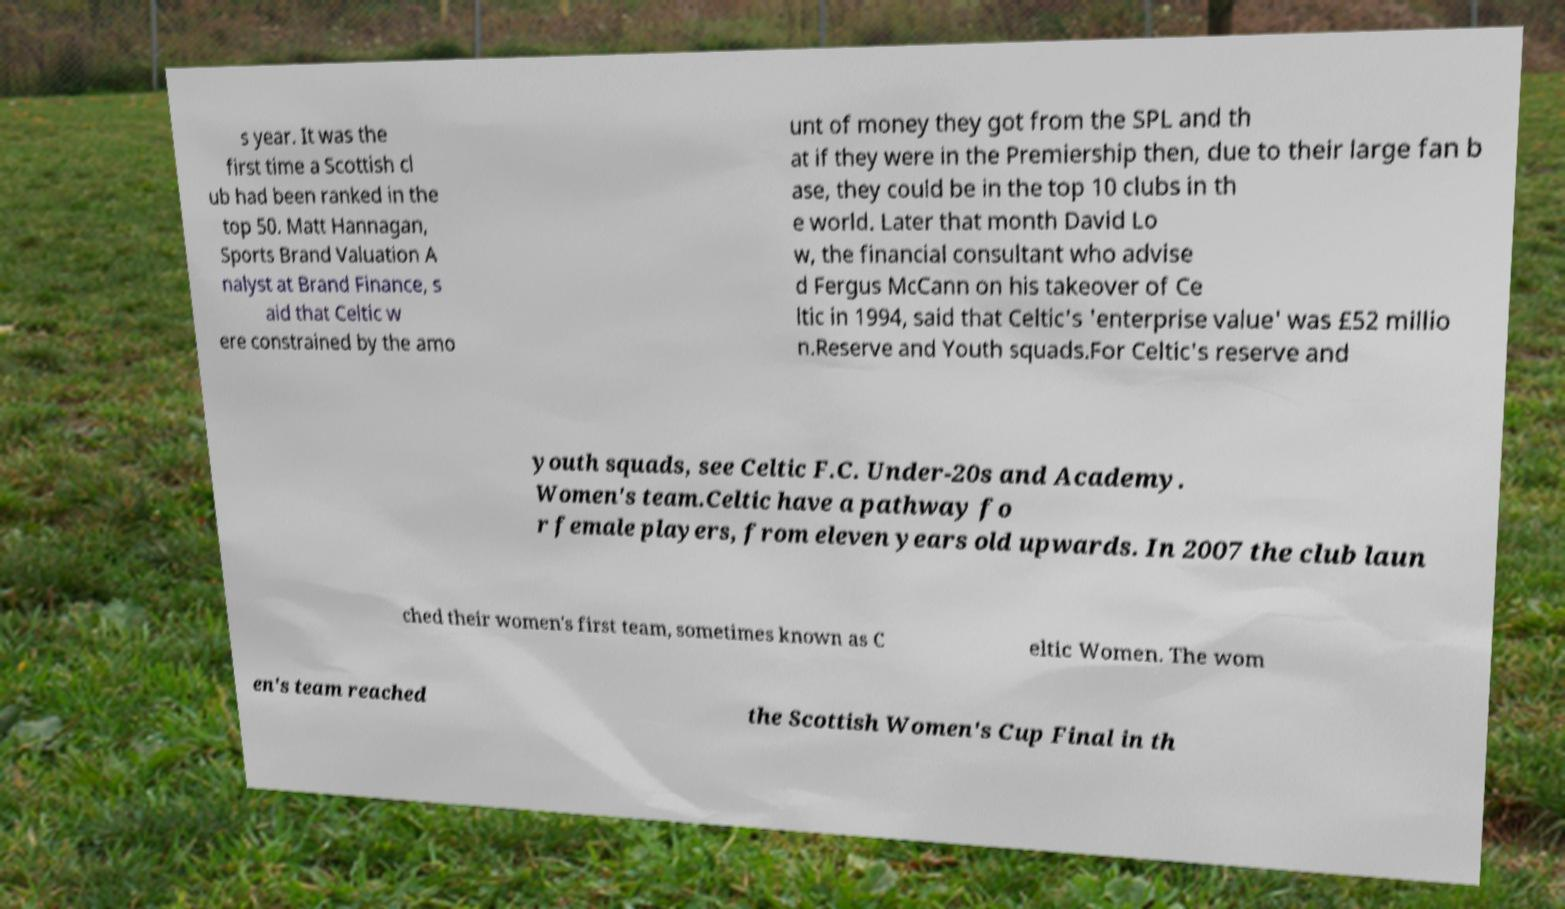Can you accurately transcribe the text from the provided image for me? s year. It was the first time a Scottish cl ub had been ranked in the top 50. Matt Hannagan, Sports Brand Valuation A nalyst at Brand Finance, s aid that Celtic w ere constrained by the amo unt of money they got from the SPL and th at if they were in the Premiership then, due to their large fan b ase, they could be in the top 10 clubs in th e world. Later that month David Lo w, the financial consultant who advise d Fergus McCann on his takeover of Ce ltic in 1994, said that Celtic's 'enterprise value' was £52 millio n.Reserve and Youth squads.For Celtic's reserve and youth squads, see Celtic F.C. Under-20s and Academy. Women's team.Celtic have a pathway fo r female players, from eleven years old upwards. In 2007 the club laun ched their women's first team, sometimes known as C eltic Women. The wom en's team reached the Scottish Women's Cup Final in th 